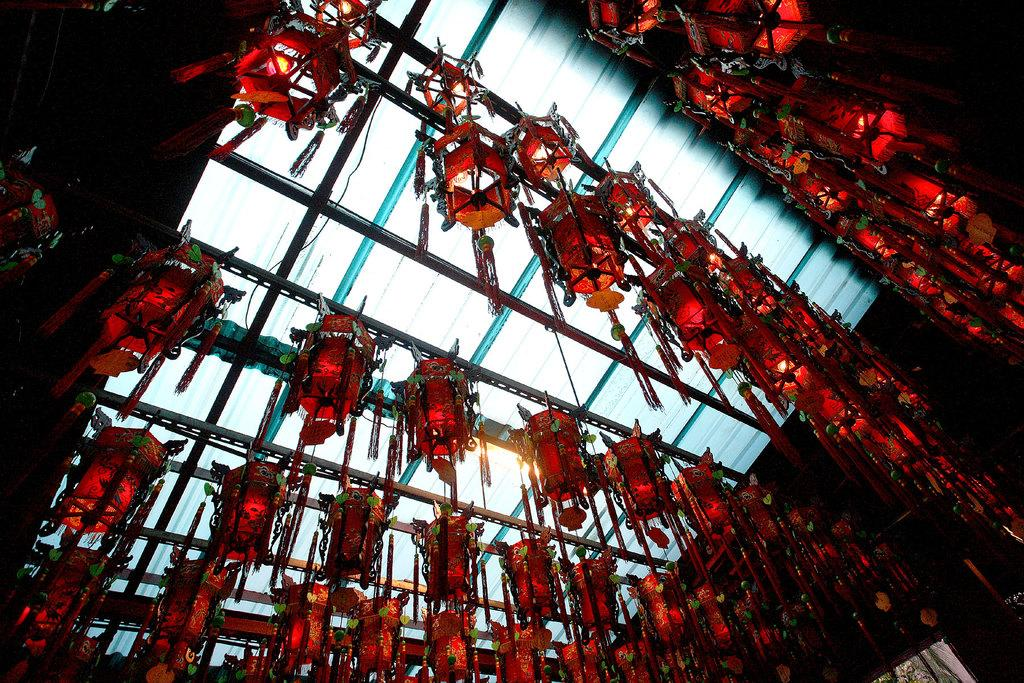What type of lighting is present in the image? There are lights in the ceiling of the image. What type of cast can be seen in the image? There is no cast present in the image; it features lights in the ceiling. What type of picture or prose is depicted in the image? There is no picture or prose depicted in the image; it only features lights in the ceiling. 